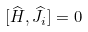<formula> <loc_0><loc_0><loc_500><loc_500>[ \widehat { H } , \widehat { J } _ { i } ] = 0</formula> 